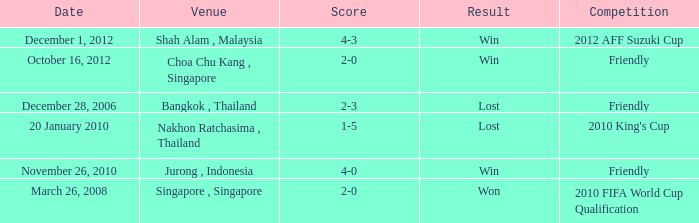Name the date for score of 1-5 20 January 2010. 